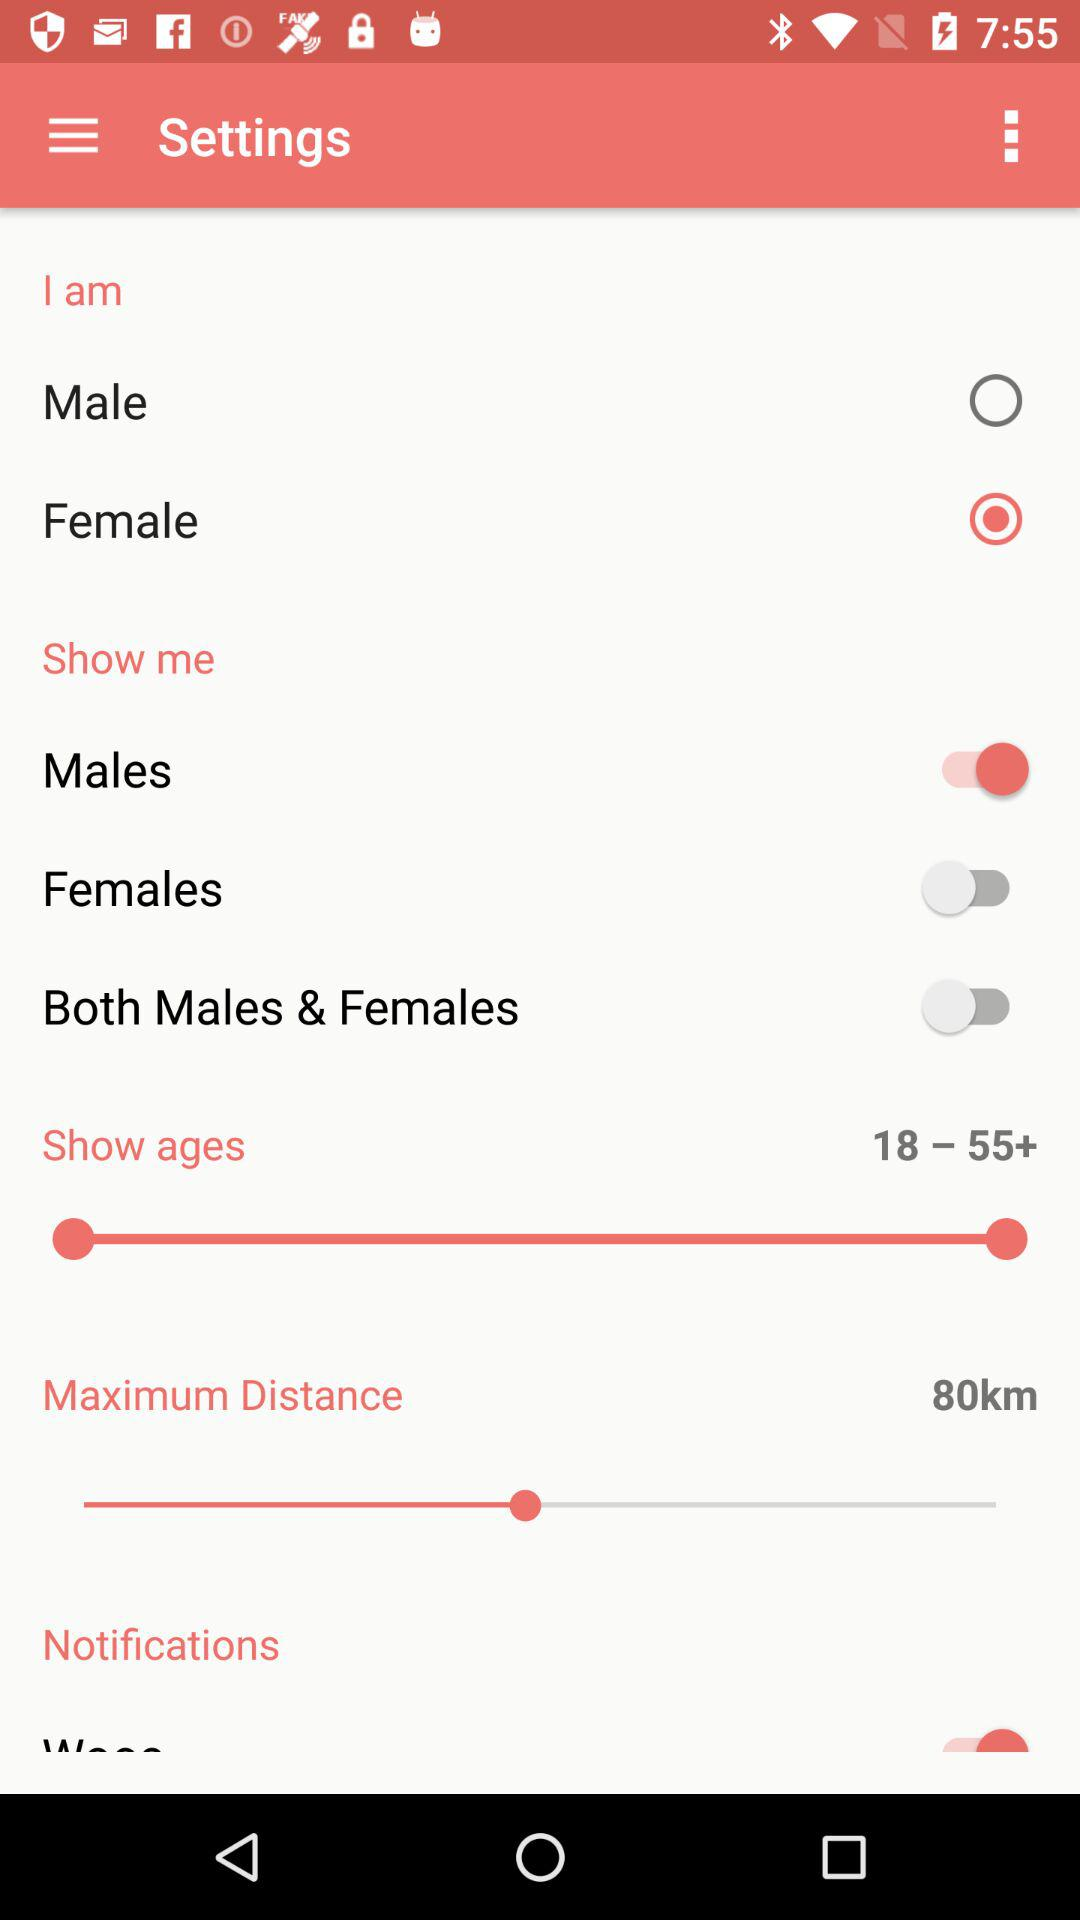Which gender option is selected? The selected gender option is "Female". 